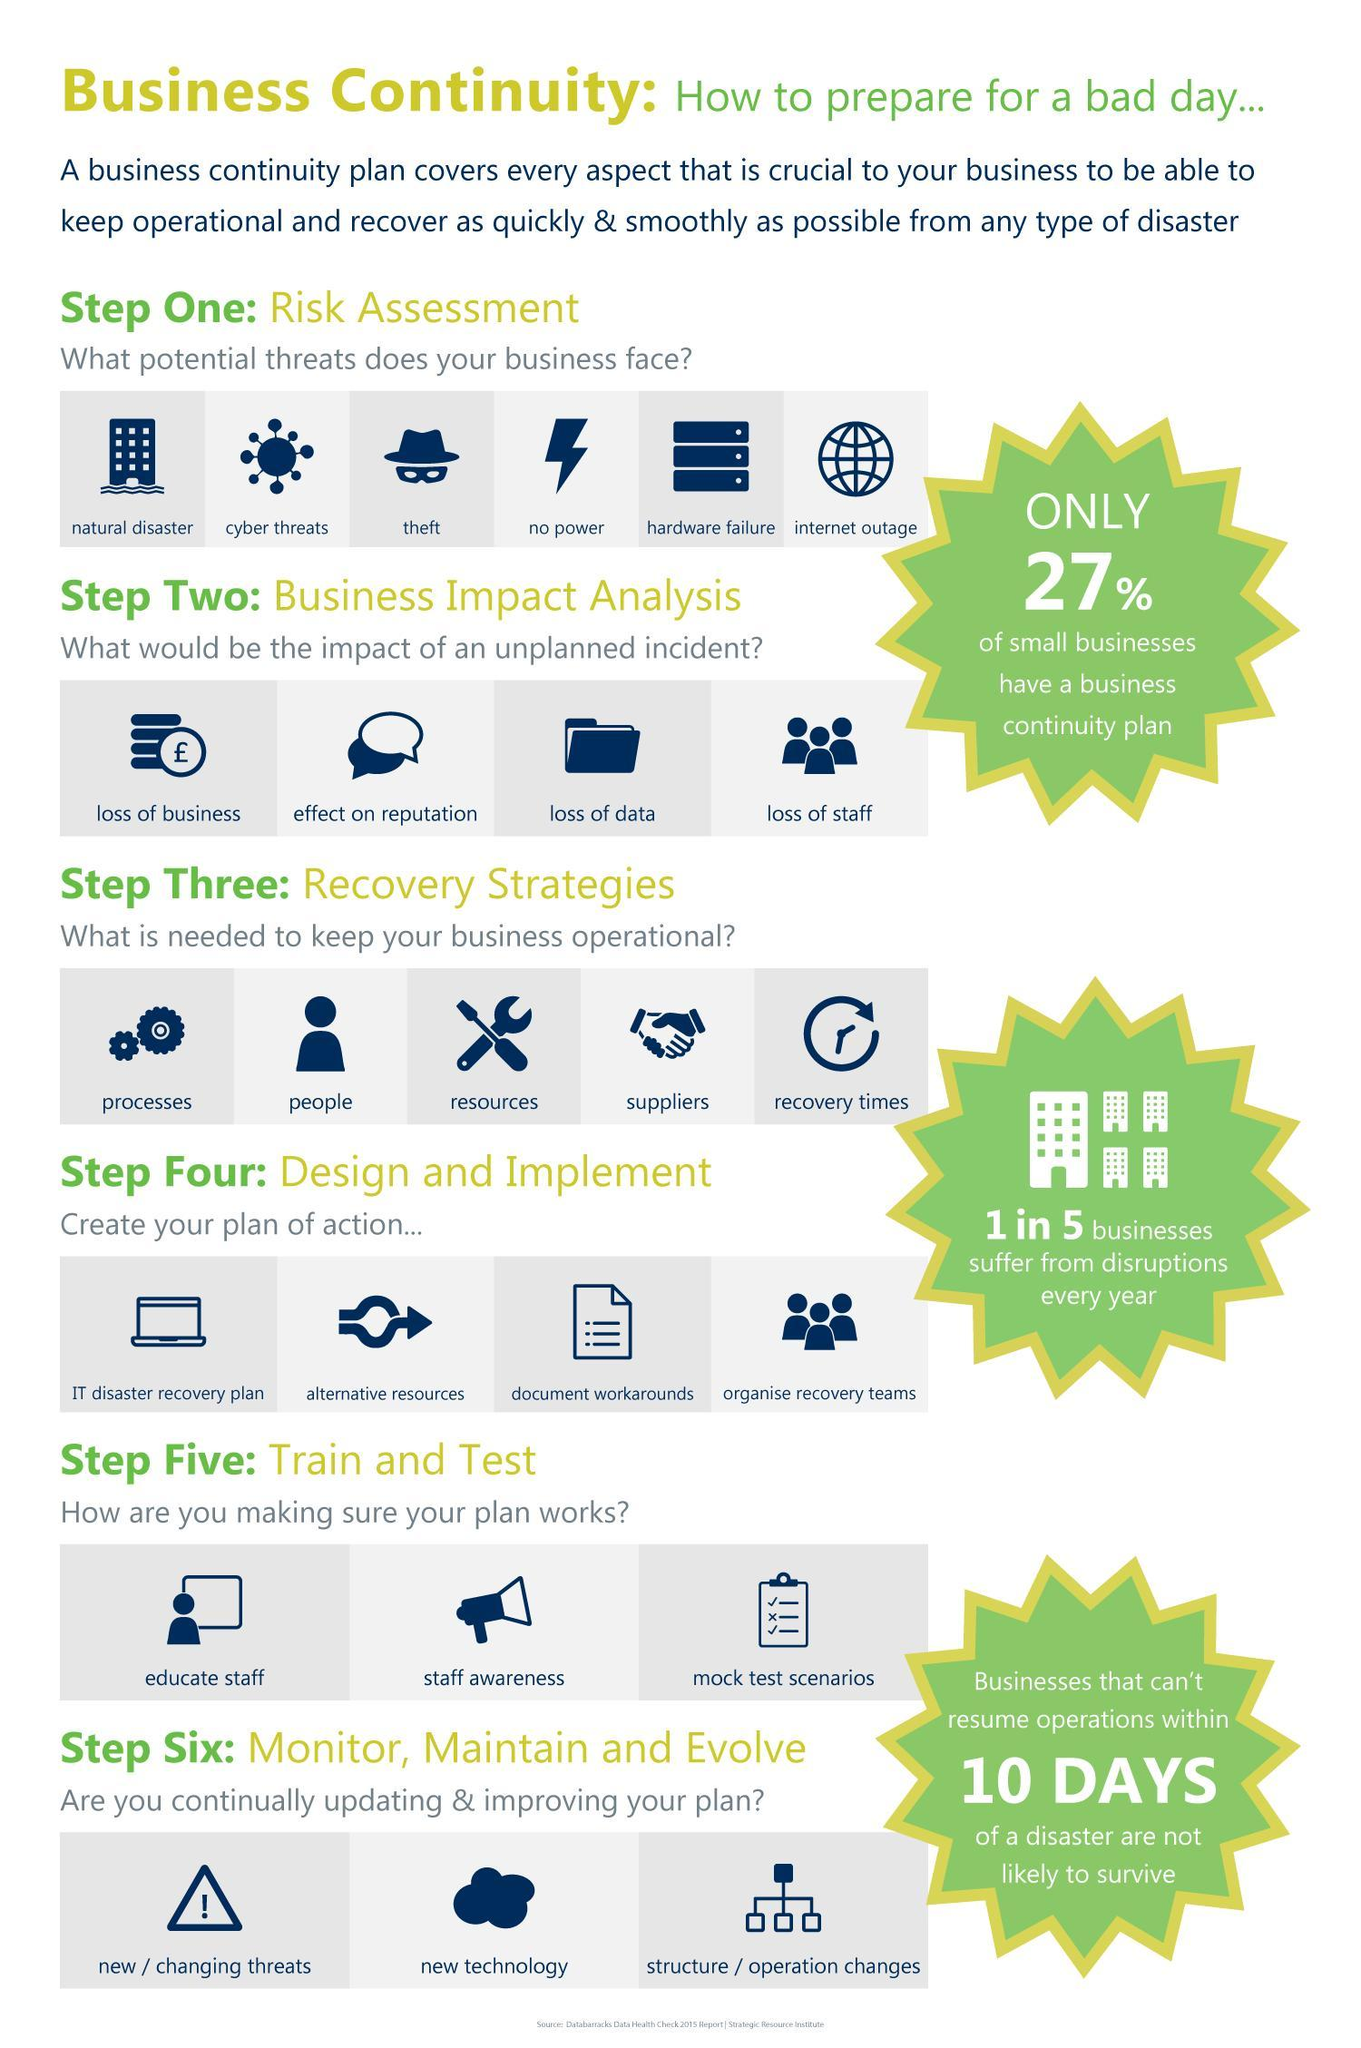What is listed second as the impact of an unplanned incident?
Answer the question with a short phrase. effect on reputation What is the fourth step when creating an action plan? organise recovery teams What is the primary step taken when designing an action plan? IT disaster recovery plan Besides loss of business, what are the other impacts of unexpected incidents on businesses? effect on reputation, loss of data, loss of staff What can be conducted to test whether the action plans work or not? mock test scenarios What is listed third among the potential threats faced by businesses? theft What is the percentage of small businesses that do not have a business continuity plan? 73% What is the second potential risk that a business might face? cyber threats What are the third and fourth factors needed to keep business operational? resources, suppliers What are the fifth and sixth potential threats that a business may face? hardware failure, internet outage 